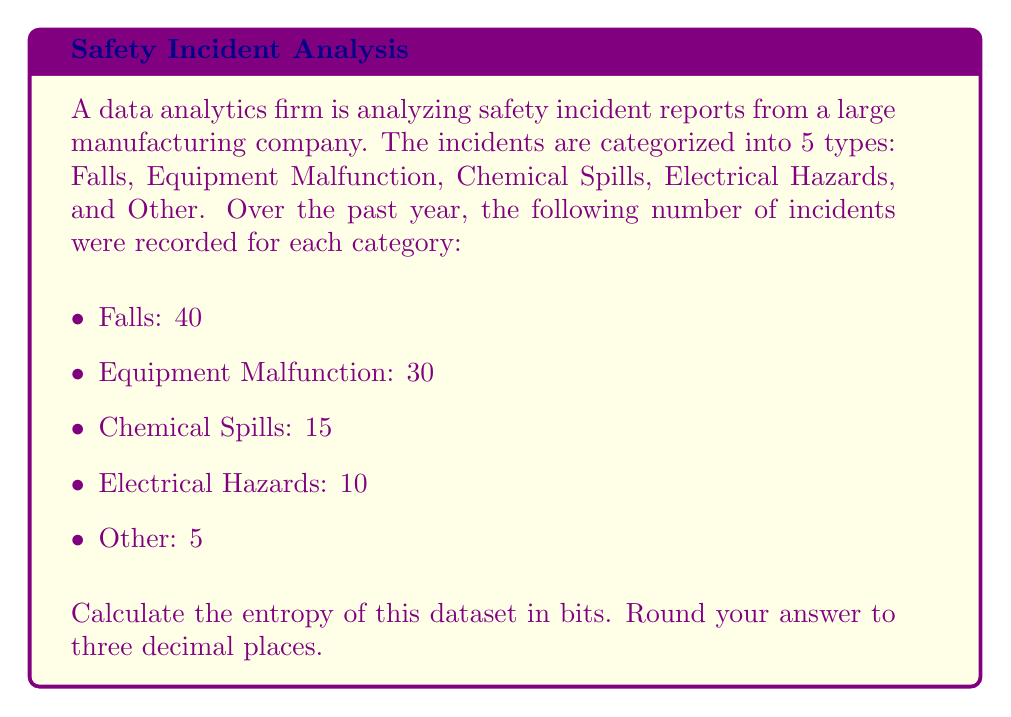Teach me how to tackle this problem. To calculate the entropy of this dataset, we'll use the formula for Shannon entropy:

$$H = -\sum_{i=1}^n p_i \log_2(p_i)$$

Where $H$ is the entropy, $p_i$ is the probability of each event, and $n$ is the number of possible events.

Steps:
1. Calculate the total number of incidents:
   $40 + 30 + 15 + 10 + 5 = 100$ total incidents

2. Calculate the probability of each type of incident:
   $p(\text{Falls}) = 40/100 = 0.4$
   $p(\text{Equipment Malfunction}) = 30/100 = 0.3$
   $p(\text{Chemical Spills}) = 15/100 = 0.15$
   $p(\text{Electrical Hazards}) = 10/100 = 0.1$
   $p(\text{Other}) = 5/100 = 0.05$

3. Calculate each term of the sum:
   $-0.4 \log_2(0.4) = 0.528321$
   $-0.3 \log_2(0.3) = 0.521061$
   $-0.15 \log_2(0.15) = 0.410244$
   $-0.1 \log_2(0.1) = 0.332193$
   $-0.05 \log_2(0.05) = 0.216096$

4. Sum all terms:
   $H = 0.528321 + 0.521061 + 0.410244 + 0.332193 + 0.216096 = 2.007915$ bits

5. Round to three decimal places:
   $H \approx 2.008$ bits
Answer: 2.008 bits 